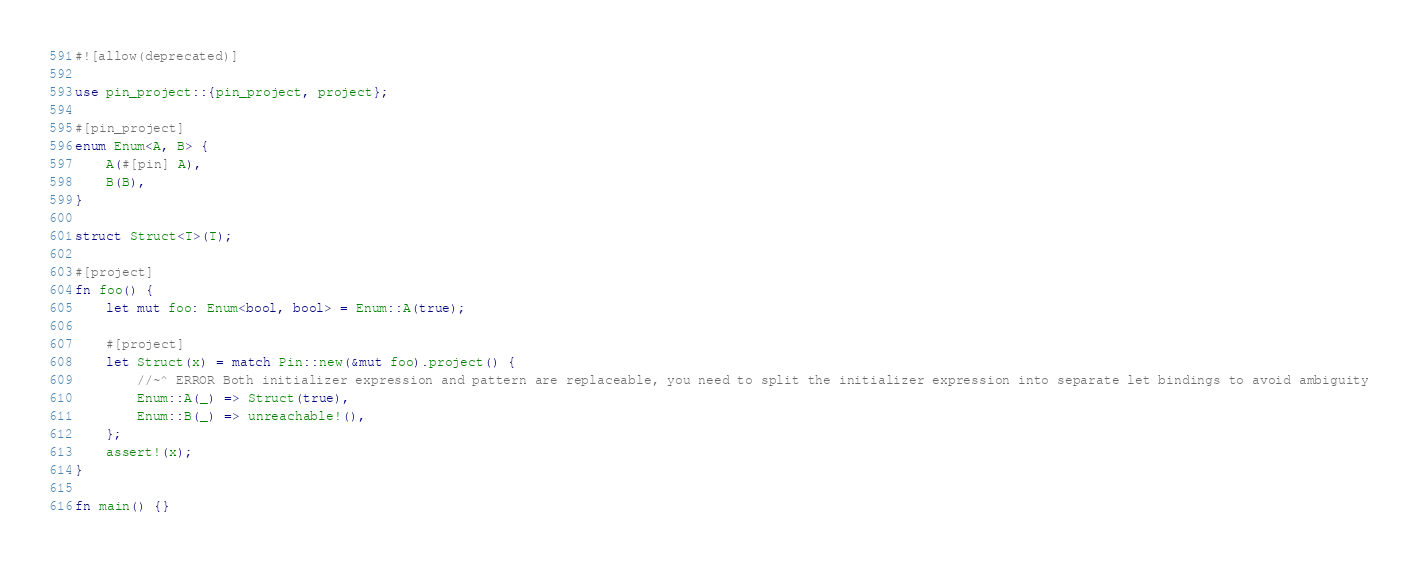Convert code to text. <code><loc_0><loc_0><loc_500><loc_500><_Rust_>#![allow(deprecated)]

use pin_project::{pin_project, project};

#[pin_project]
enum Enum<A, B> {
    A(#[pin] A),
    B(B),
}

struct Struct<T>(T);

#[project]
fn foo() {
    let mut foo: Enum<bool, bool> = Enum::A(true);

    #[project]
    let Struct(x) = match Pin::new(&mut foo).project() {
        //~^ ERROR Both initializer expression and pattern are replaceable, you need to split the initializer expression into separate let bindings to avoid ambiguity
        Enum::A(_) => Struct(true),
        Enum::B(_) => unreachable!(),
    };
    assert!(x);
}

fn main() {}
</code> 